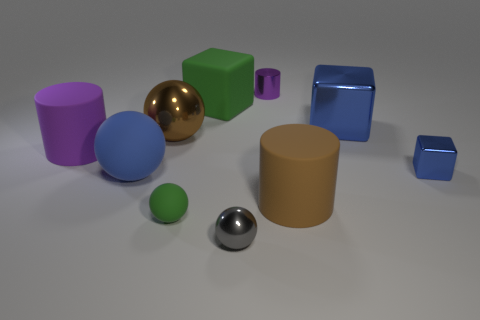Subtract 1 balls. How many balls are left? 3 Subtract all balls. How many objects are left? 6 Add 4 big green blocks. How many big green blocks are left? 5 Add 3 brown rubber cylinders. How many brown rubber cylinders exist? 4 Subtract 0 red cylinders. How many objects are left? 10 Subtract all big brown cylinders. Subtract all cylinders. How many objects are left? 6 